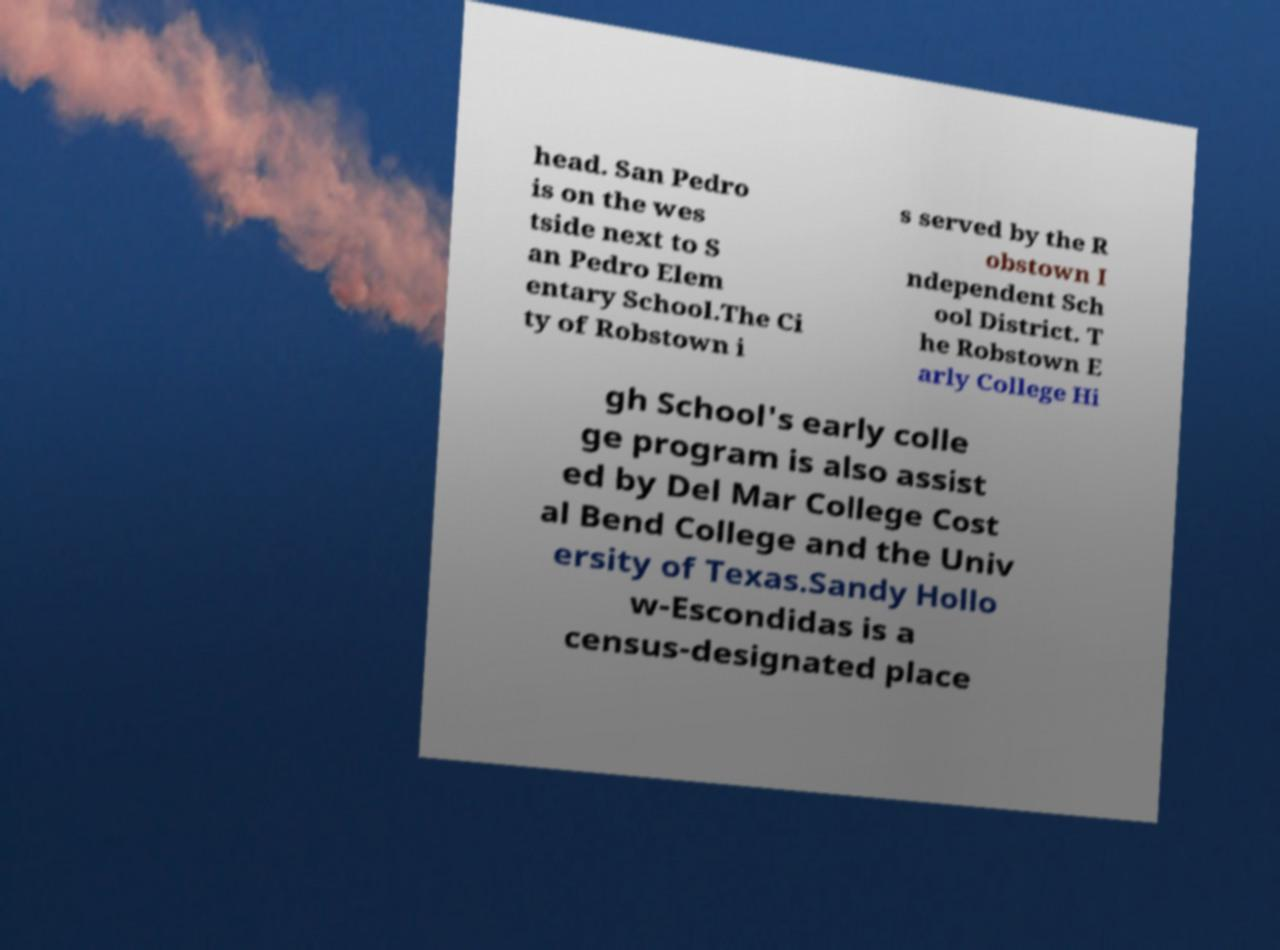Could you extract and type out the text from this image? head. San Pedro is on the wes tside next to S an Pedro Elem entary School.The Ci ty of Robstown i s served by the R obstown I ndependent Sch ool District. T he Robstown E arly College Hi gh School's early colle ge program is also assist ed by Del Mar College Cost al Bend College and the Univ ersity of Texas.Sandy Hollo w-Escondidas is a census-designated place 